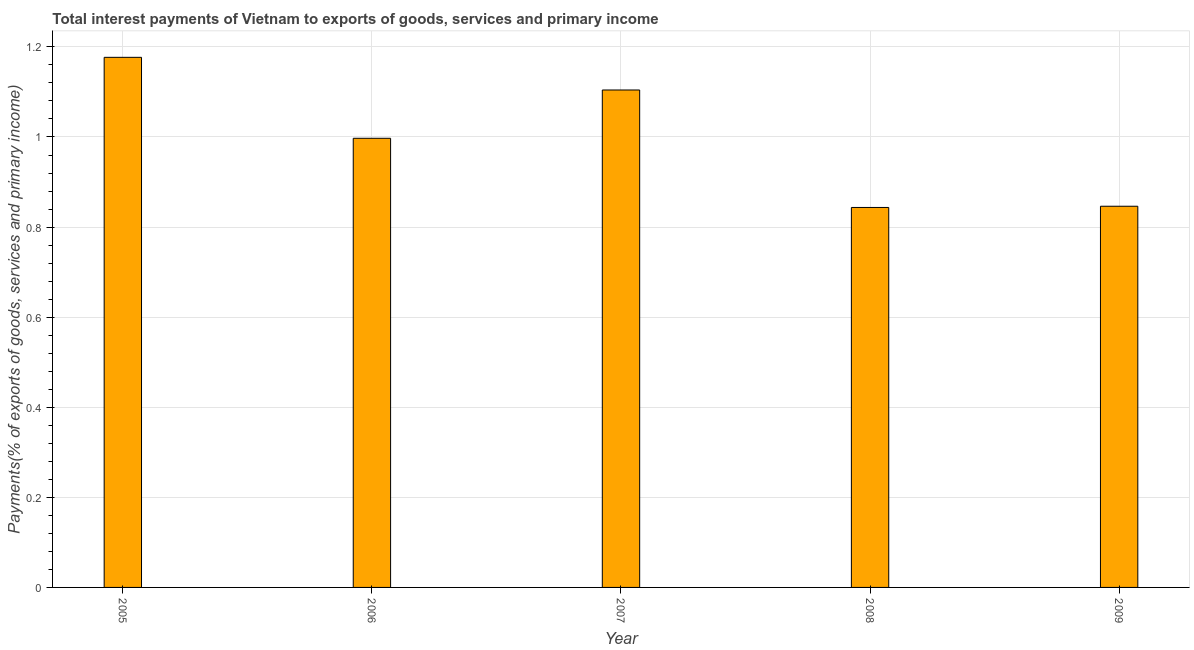What is the title of the graph?
Give a very brief answer. Total interest payments of Vietnam to exports of goods, services and primary income. What is the label or title of the X-axis?
Ensure brevity in your answer.  Year. What is the label or title of the Y-axis?
Provide a short and direct response. Payments(% of exports of goods, services and primary income). What is the total interest payments on external debt in 2005?
Offer a very short reply. 1.18. Across all years, what is the maximum total interest payments on external debt?
Provide a short and direct response. 1.18. Across all years, what is the minimum total interest payments on external debt?
Ensure brevity in your answer.  0.84. What is the sum of the total interest payments on external debt?
Give a very brief answer. 4.97. What is the difference between the total interest payments on external debt in 2007 and 2008?
Offer a terse response. 0.26. What is the average total interest payments on external debt per year?
Your answer should be very brief. 0.99. What is the median total interest payments on external debt?
Provide a succinct answer. 1. What is the ratio of the total interest payments on external debt in 2005 to that in 2008?
Offer a terse response. 1.4. What is the difference between the highest and the second highest total interest payments on external debt?
Provide a succinct answer. 0.07. Is the sum of the total interest payments on external debt in 2005 and 2009 greater than the maximum total interest payments on external debt across all years?
Make the answer very short. Yes. What is the difference between the highest and the lowest total interest payments on external debt?
Offer a very short reply. 0.33. How many bars are there?
Provide a short and direct response. 5. What is the difference between two consecutive major ticks on the Y-axis?
Provide a short and direct response. 0.2. Are the values on the major ticks of Y-axis written in scientific E-notation?
Provide a short and direct response. No. What is the Payments(% of exports of goods, services and primary income) of 2005?
Ensure brevity in your answer.  1.18. What is the Payments(% of exports of goods, services and primary income) in 2006?
Provide a short and direct response. 1. What is the Payments(% of exports of goods, services and primary income) of 2007?
Your answer should be compact. 1.1. What is the Payments(% of exports of goods, services and primary income) of 2008?
Give a very brief answer. 0.84. What is the Payments(% of exports of goods, services and primary income) of 2009?
Offer a very short reply. 0.85. What is the difference between the Payments(% of exports of goods, services and primary income) in 2005 and 2006?
Provide a succinct answer. 0.18. What is the difference between the Payments(% of exports of goods, services and primary income) in 2005 and 2007?
Offer a terse response. 0.07. What is the difference between the Payments(% of exports of goods, services and primary income) in 2005 and 2009?
Provide a succinct answer. 0.33. What is the difference between the Payments(% of exports of goods, services and primary income) in 2006 and 2007?
Your answer should be compact. -0.11. What is the difference between the Payments(% of exports of goods, services and primary income) in 2006 and 2008?
Your response must be concise. 0.15. What is the difference between the Payments(% of exports of goods, services and primary income) in 2006 and 2009?
Your answer should be very brief. 0.15. What is the difference between the Payments(% of exports of goods, services and primary income) in 2007 and 2008?
Offer a terse response. 0.26. What is the difference between the Payments(% of exports of goods, services and primary income) in 2007 and 2009?
Your response must be concise. 0.26. What is the difference between the Payments(% of exports of goods, services and primary income) in 2008 and 2009?
Your answer should be compact. -0. What is the ratio of the Payments(% of exports of goods, services and primary income) in 2005 to that in 2006?
Offer a very short reply. 1.18. What is the ratio of the Payments(% of exports of goods, services and primary income) in 2005 to that in 2007?
Provide a short and direct response. 1.07. What is the ratio of the Payments(% of exports of goods, services and primary income) in 2005 to that in 2008?
Provide a short and direct response. 1.4. What is the ratio of the Payments(% of exports of goods, services and primary income) in 2005 to that in 2009?
Your response must be concise. 1.39. What is the ratio of the Payments(% of exports of goods, services and primary income) in 2006 to that in 2007?
Your answer should be very brief. 0.9. What is the ratio of the Payments(% of exports of goods, services and primary income) in 2006 to that in 2008?
Provide a succinct answer. 1.18. What is the ratio of the Payments(% of exports of goods, services and primary income) in 2006 to that in 2009?
Provide a succinct answer. 1.18. What is the ratio of the Payments(% of exports of goods, services and primary income) in 2007 to that in 2008?
Offer a terse response. 1.31. What is the ratio of the Payments(% of exports of goods, services and primary income) in 2007 to that in 2009?
Make the answer very short. 1.3. 